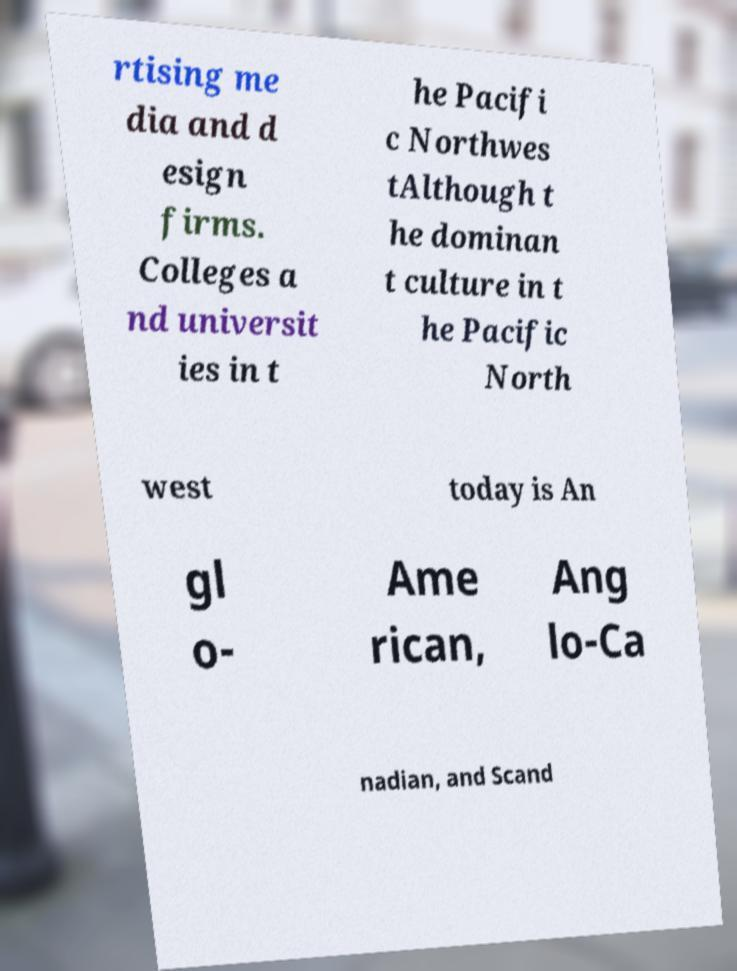Could you assist in decoding the text presented in this image and type it out clearly? rtising me dia and d esign firms. Colleges a nd universit ies in t he Pacifi c Northwes tAlthough t he dominan t culture in t he Pacific North west today is An gl o- Ame rican, Ang lo-Ca nadian, and Scand 